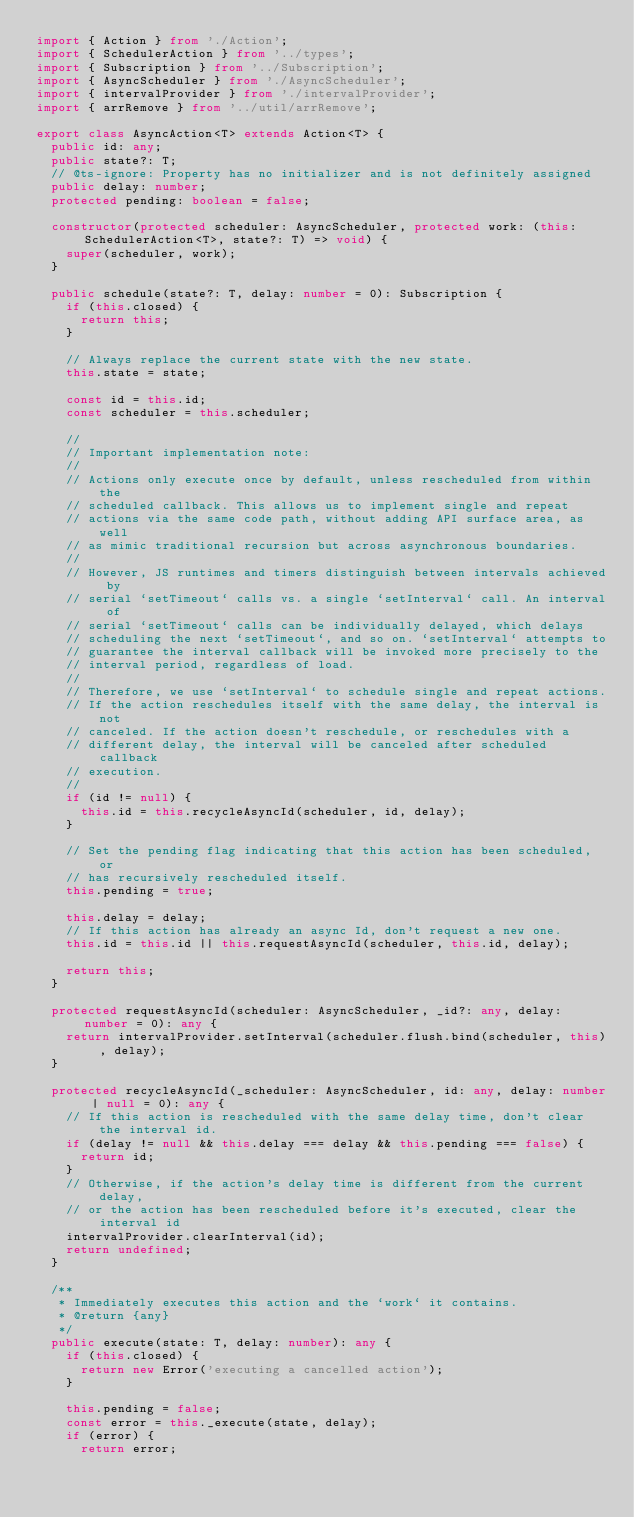<code> <loc_0><loc_0><loc_500><loc_500><_TypeScript_>import { Action } from './Action';
import { SchedulerAction } from '../types';
import { Subscription } from '../Subscription';
import { AsyncScheduler } from './AsyncScheduler';
import { intervalProvider } from './intervalProvider';
import { arrRemove } from '../util/arrRemove';

export class AsyncAction<T> extends Action<T> {
  public id: any;
  public state?: T;
  // @ts-ignore: Property has no initializer and is not definitely assigned
  public delay: number;
  protected pending: boolean = false;

  constructor(protected scheduler: AsyncScheduler, protected work: (this: SchedulerAction<T>, state?: T) => void) {
    super(scheduler, work);
  }

  public schedule(state?: T, delay: number = 0): Subscription {
    if (this.closed) {
      return this;
    }

    // Always replace the current state with the new state.
    this.state = state;

    const id = this.id;
    const scheduler = this.scheduler;

    //
    // Important implementation note:
    //
    // Actions only execute once by default, unless rescheduled from within the
    // scheduled callback. This allows us to implement single and repeat
    // actions via the same code path, without adding API surface area, as well
    // as mimic traditional recursion but across asynchronous boundaries.
    //
    // However, JS runtimes and timers distinguish between intervals achieved by
    // serial `setTimeout` calls vs. a single `setInterval` call. An interval of
    // serial `setTimeout` calls can be individually delayed, which delays
    // scheduling the next `setTimeout`, and so on. `setInterval` attempts to
    // guarantee the interval callback will be invoked more precisely to the
    // interval period, regardless of load.
    //
    // Therefore, we use `setInterval` to schedule single and repeat actions.
    // If the action reschedules itself with the same delay, the interval is not
    // canceled. If the action doesn't reschedule, or reschedules with a
    // different delay, the interval will be canceled after scheduled callback
    // execution.
    //
    if (id != null) {
      this.id = this.recycleAsyncId(scheduler, id, delay);
    }

    // Set the pending flag indicating that this action has been scheduled, or
    // has recursively rescheduled itself.
    this.pending = true;

    this.delay = delay;
    // If this action has already an async Id, don't request a new one.
    this.id = this.id || this.requestAsyncId(scheduler, this.id, delay);

    return this;
  }

  protected requestAsyncId(scheduler: AsyncScheduler, _id?: any, delay: number = 0): any {
    return intervalProvider.setInterval(scheduler.flush.bind(scheduler, this), delay);
  }

  protected recycleAsyncId(_scheduler: AsyncScheduler, id: any, delay: number | null = 0): any {
    // If this action is rescheduled with the same delay time, don't clear the interval id.
    if (delay != null && this.delay === delay && this.pending === false) {
      return id;
    }
    // Otherwise, if the action's delay time is different from the current delay,
    // or the action has been rescheduled before it's executed, clear the interval id
    intervalProvider.clearInterval(id);
    return undefined;
  }

  /**
   * Immediately executes this action and the `work` it contains.
   * @return {any}
   */
  public execute(state: T, delay: number): any {
    if (this.closed) {
      return new Error('executing a cancelled action');
    }

    this.pending = false;
    const error = this._execute(state, delay);
    if (error) {
      return error;</code> 